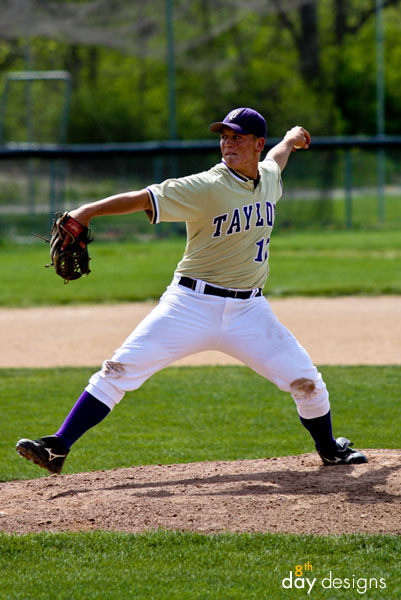Identify and read out the text in this image. TAYLO 13 designs th 8 